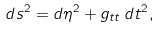Convert formula to latex. <formula><loc_0><loc_0><loc_500><loc_500>d s ^ { 2 } = d \eta ^ { 2 } + g _ { t t } \, d t ^ { 2 } ,</formula> 